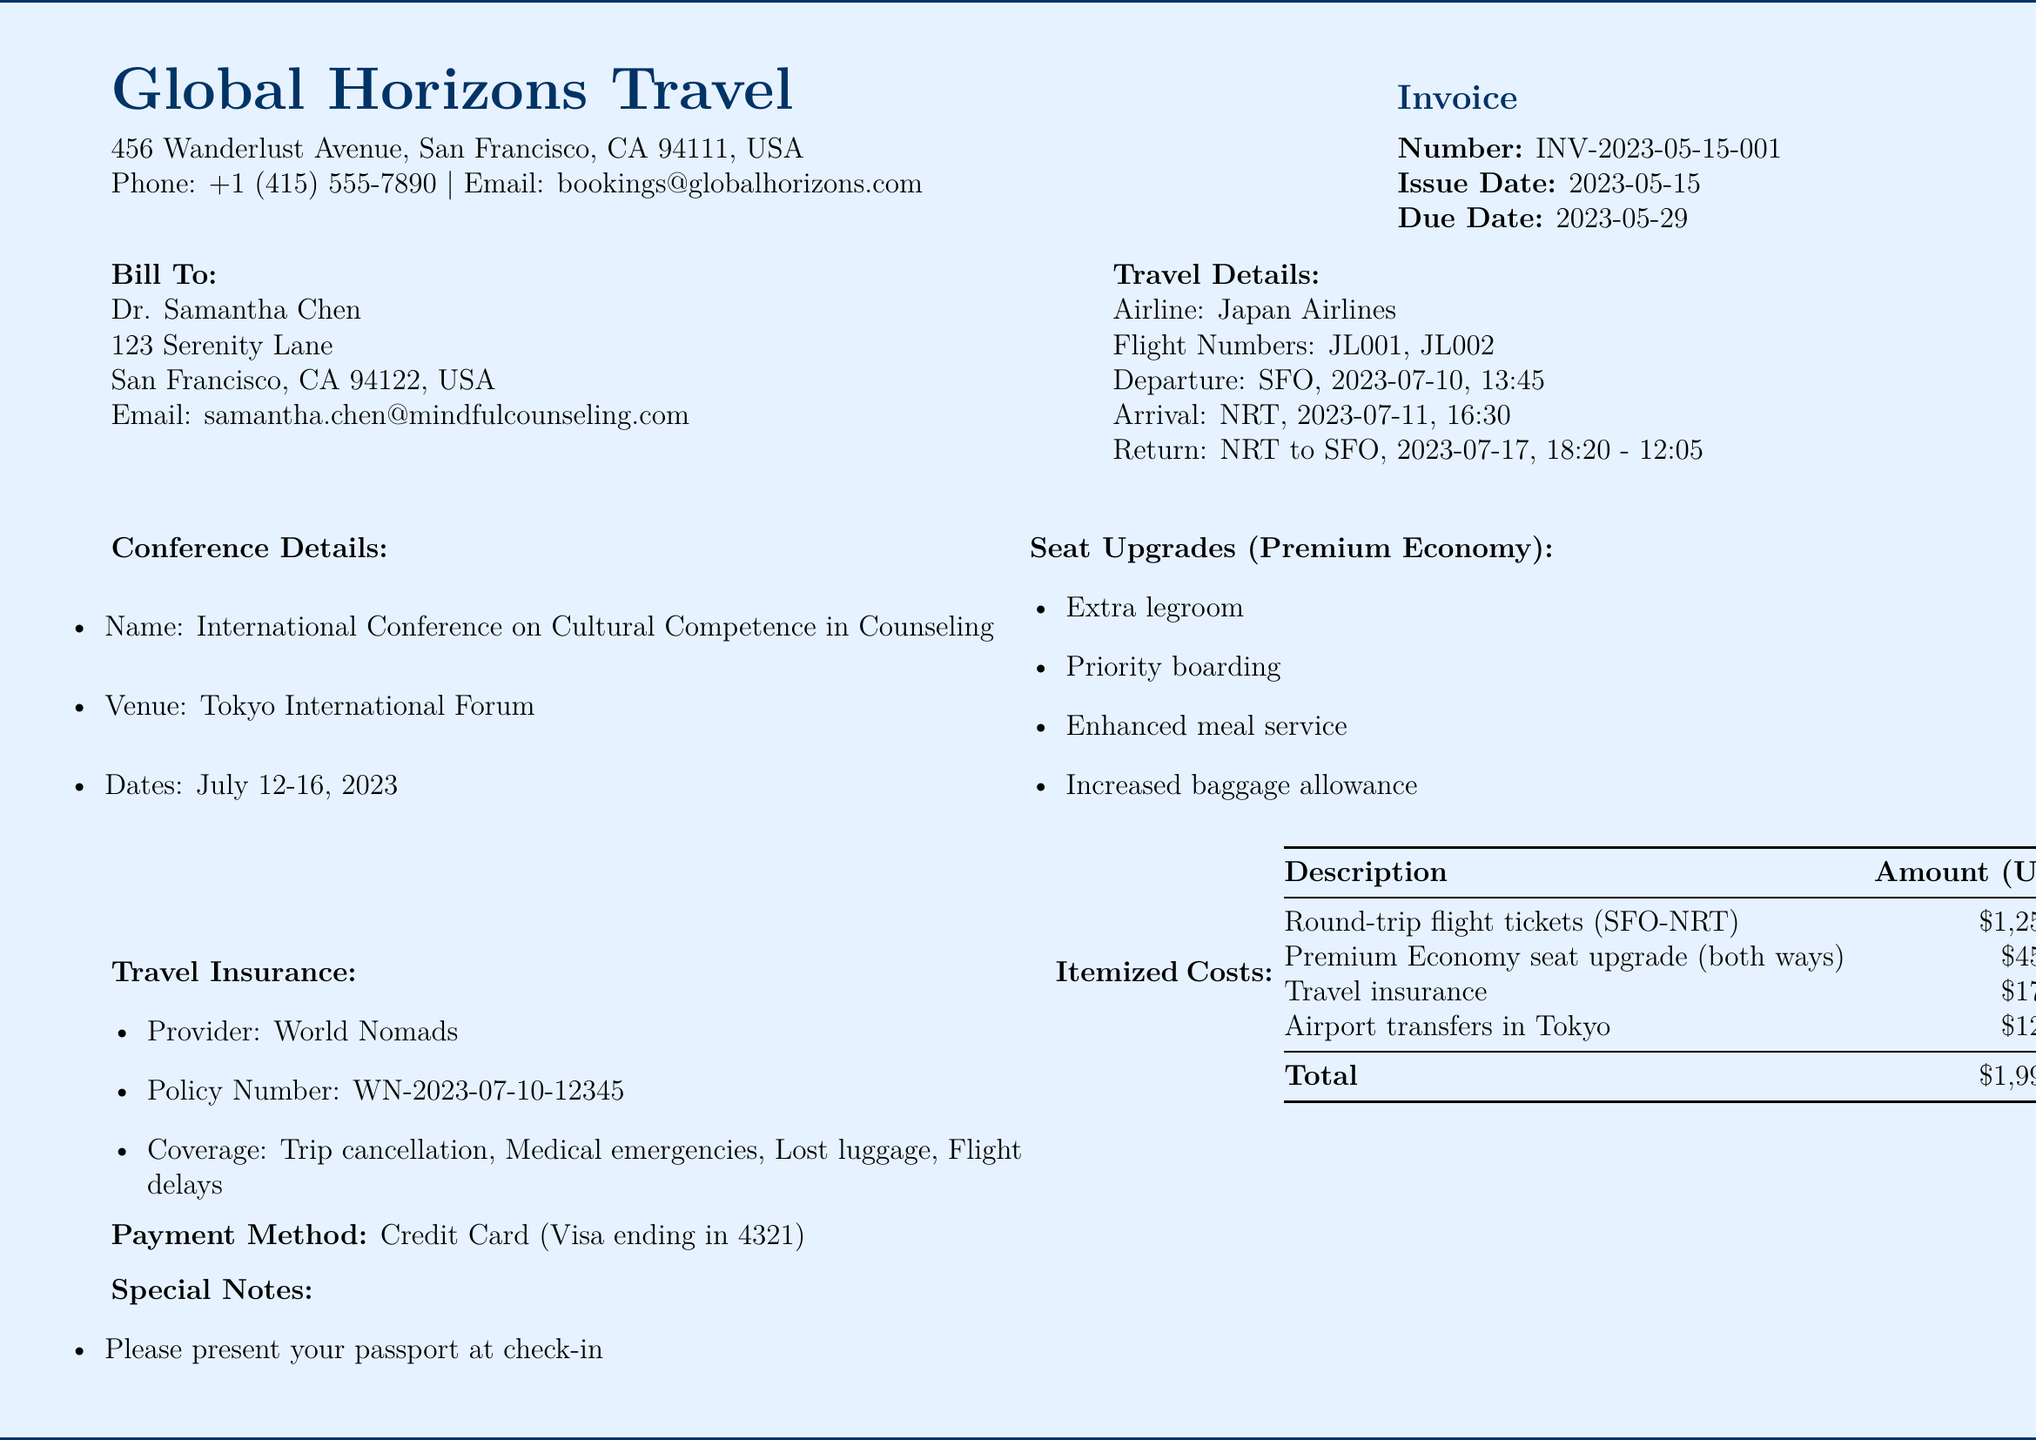What is the invoice number? The invoice number can be found at the top of the document under the invoice details.
Answer: INV-2023-05-15-001 Who is the client? The client's name is listed in the billing section of the document under "Bill To."
Answer: Dr. Samantha Chen What is the total amount due? The total amount is indicated in the itemized costs section of the document.
Answer: 1995.00 What is the departure airport? The departure airport can be found in the flight details section of the document.
Answer: San Francisco International Airport (SFO) Which airline is being used for the flights? The airline name is provided in the travel details section of the document.
Answer: Japan Airlines What are the dates of the conference? The dates for the conference are specified in the conference details of the document.
Answer: July 12-16, 2023 What is included in the travel insurance coverage? The coverage items are listed in the travel insurance section of the document.
Answer: Trip cancellation, Medical emergencies, Lost luggage, Flight delays How much is the seat upgrade cost? The seat upgrade cost is shown in the itemized costs table of the document.
Answer: 450.00 What special note is provided regarding airport arrival? Special notes regarding airport arrival are found in the special notes section of the document.
Answer: Arrive at the airport at least 3 hours before departure 